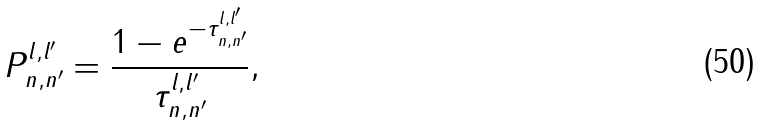<formula> <loc_0><loc_0><loc_500><loc_500>P _ { n , n ^ { \prime } } ^ { l , l ^ { \prime } } = \frac { 1 - e ^ { - \tau _ { n , n ^ { \prime } } ^ { l , l ^ { \prime } } } } { \tau _ { n , n ^ { \prime } } ^ { l , l ^ { \prime } } } ,</formula> 